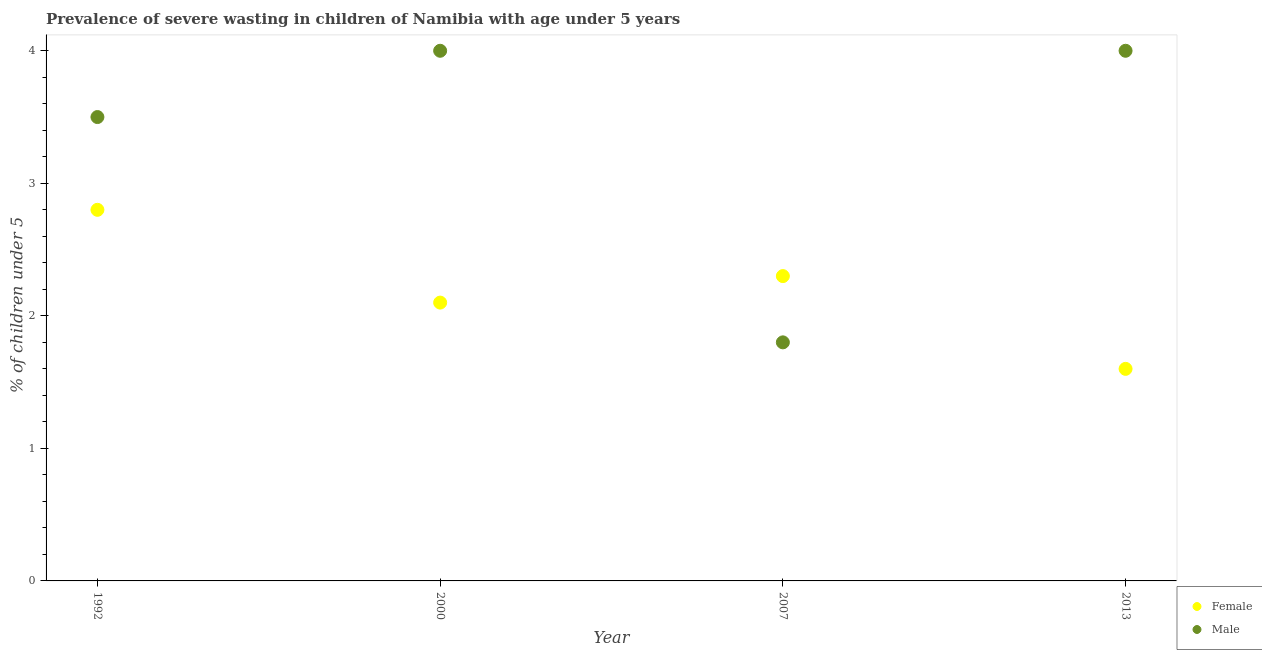What is the percentage of undernourished female children in 2007?
Your answer should be very brief. 2.3. Across all years, what is the maximum percentage of undernourished female children?
Offer a terse response. 2.8. Across all years, what is the minimum percentage of undernourished male children?
Offer a very short reply. 1.8. In which year was the percentage of undernourished female children maximum?
Your answer should be very brief. 1992. In which year was the percentage of undernourished male children minimum?
Ensure brevity in your answer.  2007. What is the total percentage of undernourished male children in the graph?
Offer a very short reply. 13.3. What is the difference between the percentage of undernourished male children in 1992 and that in 2013?
Give a very brief answer. -0.5. What is the difference between the percentage of undernourished male children in 2013 and the percentage of undernourished female children in 2000?
Provide a succinct answer. 1.9. What is the average percentage of undernourished male children per year?
Make the answer very short. 3.32. In the year 2000, what is the difference between the percentage of undernourished male children and percentage of undernourished female children?
Provide a succinct answer. 1.9. In how many years, is the percentage of undernourished female children greater than 0.4 %?
Provide a succinct answer. 4. What is the ratio of the percentage of undernourished female children in 1992 to that in 2013?
Offer a very short reply. 1.75. Is the difference between the percentage of undernourished female children in 2000 and 2007 greater than the difference between the percentage of undernourished male children in 2000 and 2007?
Offer a terse response. No. What is the difference between the highest and the lowest percentage of undernourished male children?
Your answer should be compact. 2.2. In how many years, is the percentage of undernourished male children greater than the average percentage of undernourished male children taken over all years?
Give a very brief answer. 3. Is the sum of the percentage of undernourished male children in 1992 and 2013 greater than the maximum percentage of undernourished female children across all years?
Give a very brief answer. Yes. Does the percentage of undernourished female children monotonically increase over the years?
Give a very brief answer. No. Is the percentage of undernourished female children strictly less than the percentage of undernourished male children over the years?
Provide a short and direct response. No. How many dotlines are there?
Offer a very short reply. 2. How many years are there in the graph?
Your answer should be very brief. 4. Are the values on the major ticks of Y-axis written in scientific E-notation?
Your answer should be very brief. No. Does the graph contain any zero values?
Give a very brief answer. No. Does the graph contain grids?
Provide a short and direct response. No. Where does the legend appear in the graph?
Ensure brevity in your answer.  Bottom right. How many legend labels are there?
Make the answer very short. 2. What is the title of the graph?
Ensure brevity in your answer.  Prevalence of severe wasting in children of Namibia with age under 5 years. Does "IMF concessional" appear as one of the legend labels in the graph?
Provide a succinct answer. No. What is the label or title of the Y-axis?
Keep it short and to the point.  % of children under 5. What is the  % of children under 5 of Female in 1992?
Your answer should be compact. 2.8. What is the  % of children under 5 of Male in 1992?
Your answer should be compact. 3.5. What is the  % of children under 5 in Female in 2000?
Your answer should be compact. 2.1. What is the  % of children under 5 in Male in 2000?
Your answer should be compact. 4. What is the  % of children under 5 of Female in 2007?
Provide a short and direct response. 2.3. What is the  % of children under 5 of Male in 2007?
Offer a terse response. 1.8. What is the  % of children under 5 in Female in 2013?
Keep it short and to the point. 1.6. Across all years, what is the maximum  % of children under 5 of Female?
Provide a succinct answer. 2.8. Across all years, what is the maximum  % of children under 5 of Male?
Keep it short and to the point. 4. Across all years, what is the minimum  % of children under 5 in Female?
Provide a succinct answer. 1.6. Across all years, what is the minimum  % of children under 5 of Male?
Give a very brief answer. 1.8. What is the total  % of children under 5 of Female in the graph?
Provide a short and direct response. 8.8. What is the difference between the  % of children under 5 in Female in 1992 and that in 2000?
Give a very brief answer. 0.7. What is the difference between the  % of children under 5 of Female in 1992 and that in 2007?
Provide a short and direct response. 0.5. What is the difference between the  % of children under 5 of Male in 1992 and that in 2007?
Give a very brief answer. 1.7. What is the difference between the  % of children under 5 of Female in 1992 and that in 2013?
Give a very brief answer. 1.2. What is the difference between the  % of children under 5 in Female in 2000 and that in 2007?
Your answer should be compact. -0.2. What is the difference between the  % of children under 5 of Male in 2000 and that in 2007?
Keep it short and to the point. 2.2. What is the difference between the  % of children under 5 of Male in 2007 and that in 2013?
Provide a succinct answer. -2.2. What is the difference between the  % of children under 5 of Female in 1992 and the  % of children under 5 of Male in 2007?
Offer a very short reply. 1. What is the difference between the  % of children under 5 in Female in 1992 and the  % of children under 5 in Male in 2013?
Give a very brief answer. -1.2. What is the difference between the  % of children under 5 in Female in 2000 and the  % of children under 5 in Male in 2013?
Keep it short and to the point. -1.9. What is the difference between the  % of children under 5 in Female in 2007 and the  % of children under 5 in Male in 2013?
Make the answer very short. -1.7. What is the average  % of children under 5 in Male per year?
Provide a short and direct response. 3.33. In the year 2007, what is the difference between the  % of children under 5 of Female and  % of children under 5 of Male?
Your answer should be very brief. 0.5. In the year 2013, what is the difference between the  % of children under 5 of Female and  % of children under 5 of Male?
Provide a succinct answer. -2.4. What is the ratio of the  % of children under 5 in Female in 1992 to that in 2007?
Provide a succinct answer. 1.22. What is the ratio of the  % of children under 5 in Male in 1992 to that in 2007?
Your response must be concise. 1.94. What is the ratio of the  % of children under 5 of Female in 1992 to that in 2013?
Your answer should be very brief. 1.75. What is the ratio of the  % of children under 5 in Male in 1992 to that in 2013?
Give a very brief answer. 0.88. What is the ratio of the  % of children under 5 of Female in 2000 to that in 2007?
Your answer should be compact. 0.91. What is the ratio of the  % of children under 5 in Male in 2000 to that in 2007?
Make the answer very short. 2.22. What is the ratio of the  % of children under 5 of Female in 2000 to that in 2013?
Your response must be concise. 1.31. What is the ratio of the  % of children under 5 of Male in 2000 to that in 2013?
Your answer should be compact. 1. What is the ratio of the  % of children under 5 of Female in 2007 to that in 2013?
Make the answer very short. 1.44. What is the ratio of the  % of children under 5 in Male in 2007 to that in 2013?
Your response must be concise. 0.45. What is the difference between the highest and the second highest  % of children under 5 in Female?
Provide a short and direct response. 0.5. What is the difference between the highest and the lowest  % of children under 5 in Female?
Make the answer very short. 1.2. 